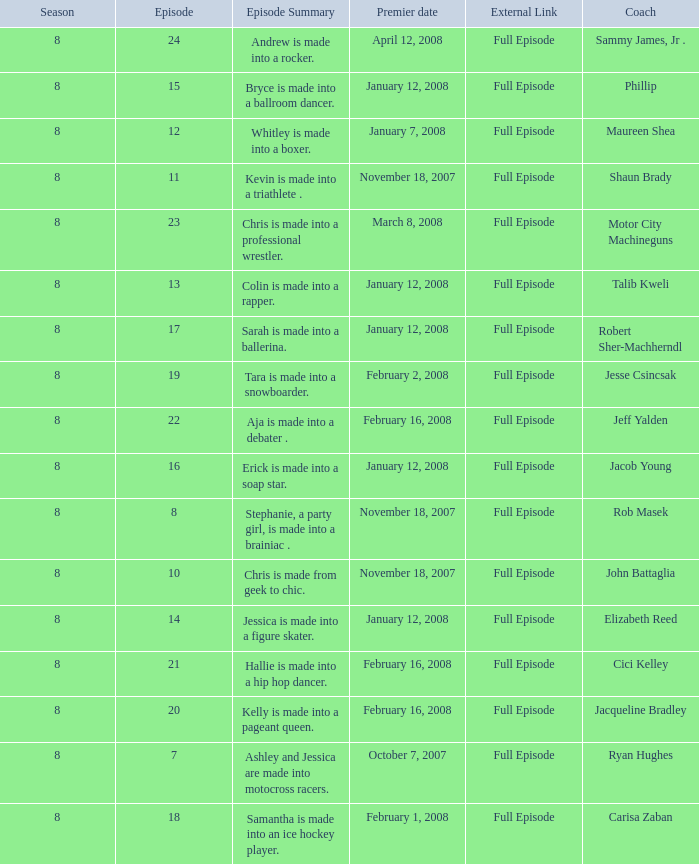What coach premiered February 16, 2008 later than episode 21.0? Jeff Yalden. 